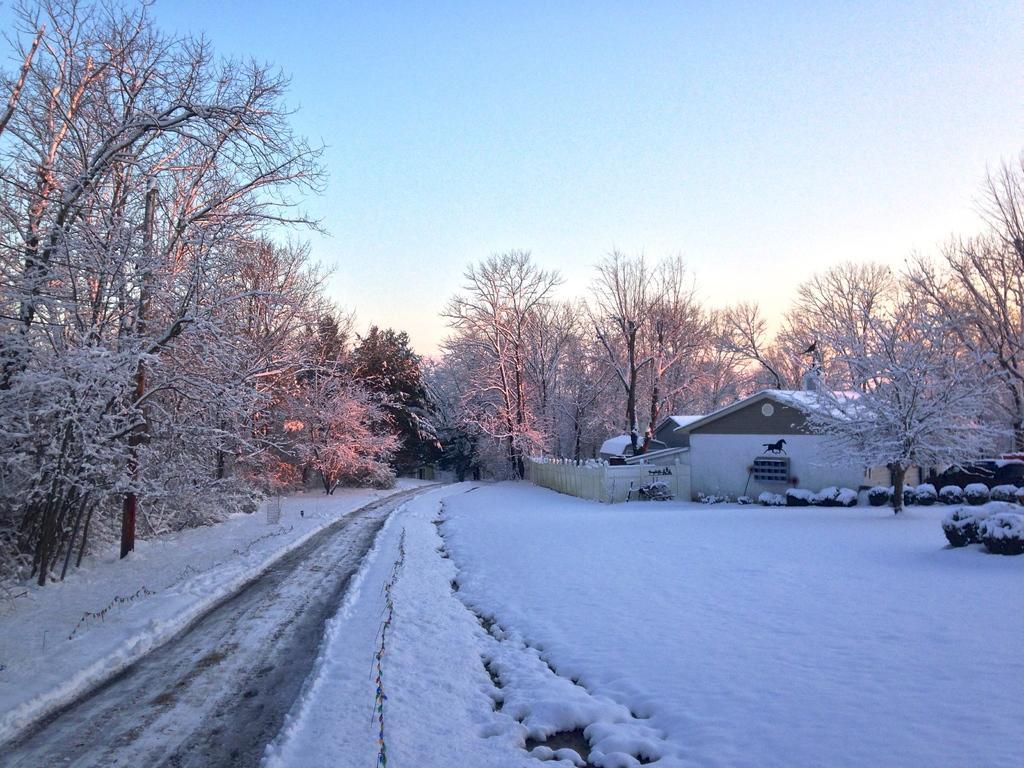Please provide a concise description of this image. This image is clicked on the road. There is snow on the ground. On the either sides of the road there are trees. There is a house in the image. There is a wooden fence around the house. At the top there is the sky. 